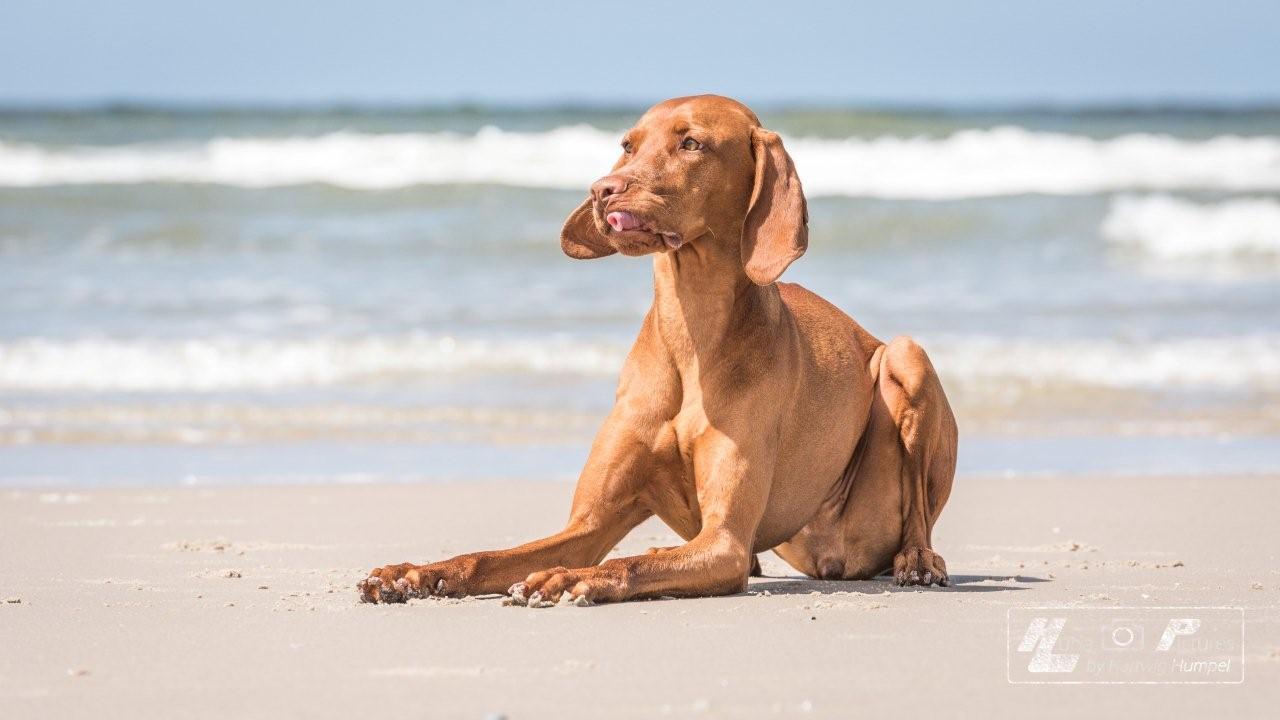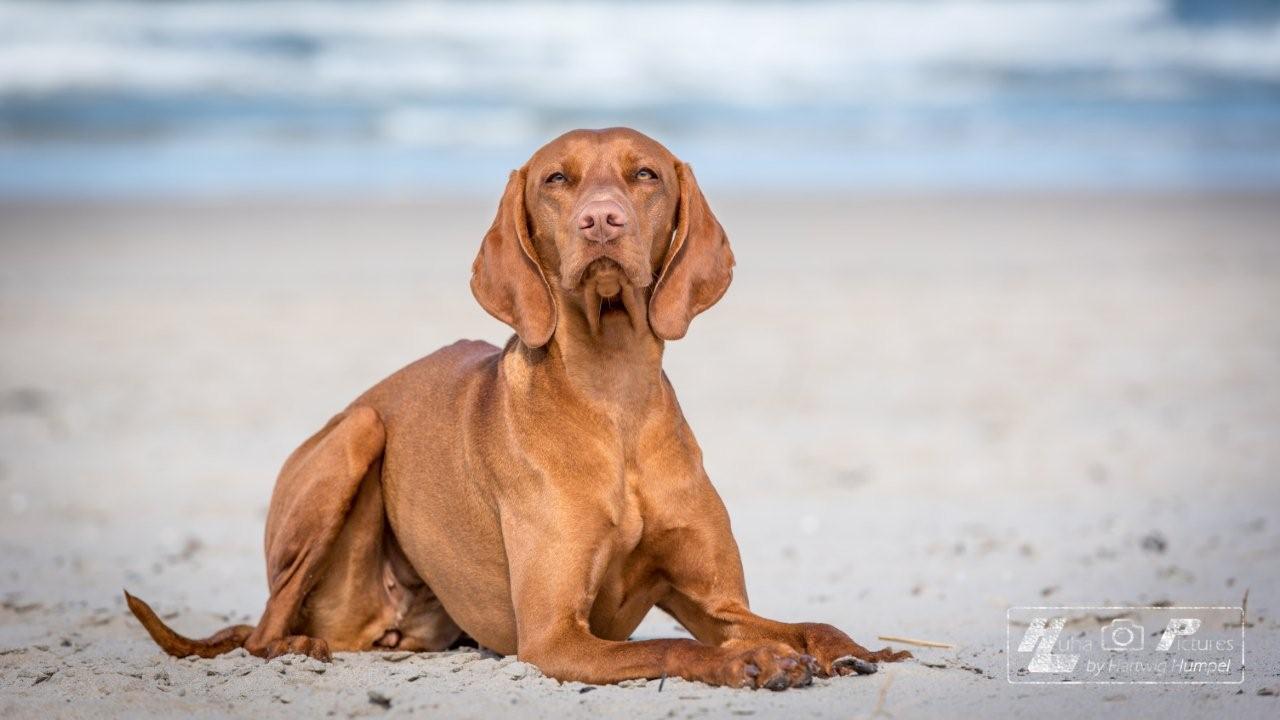The first image is the image on the left, the second image is the image on the right. Evaluate the accuracy of this statement regarding the images: "Left and right images show an orange dog at the beach, and at least one image shows a dog that is not in the water.". Is it true? Answer yes or no. Yes. The first image is the image on the left, the second image is the image on the right. Considering the images on both sides, is "There are at least three dogs in total." valid? Answer yes or no. No. 